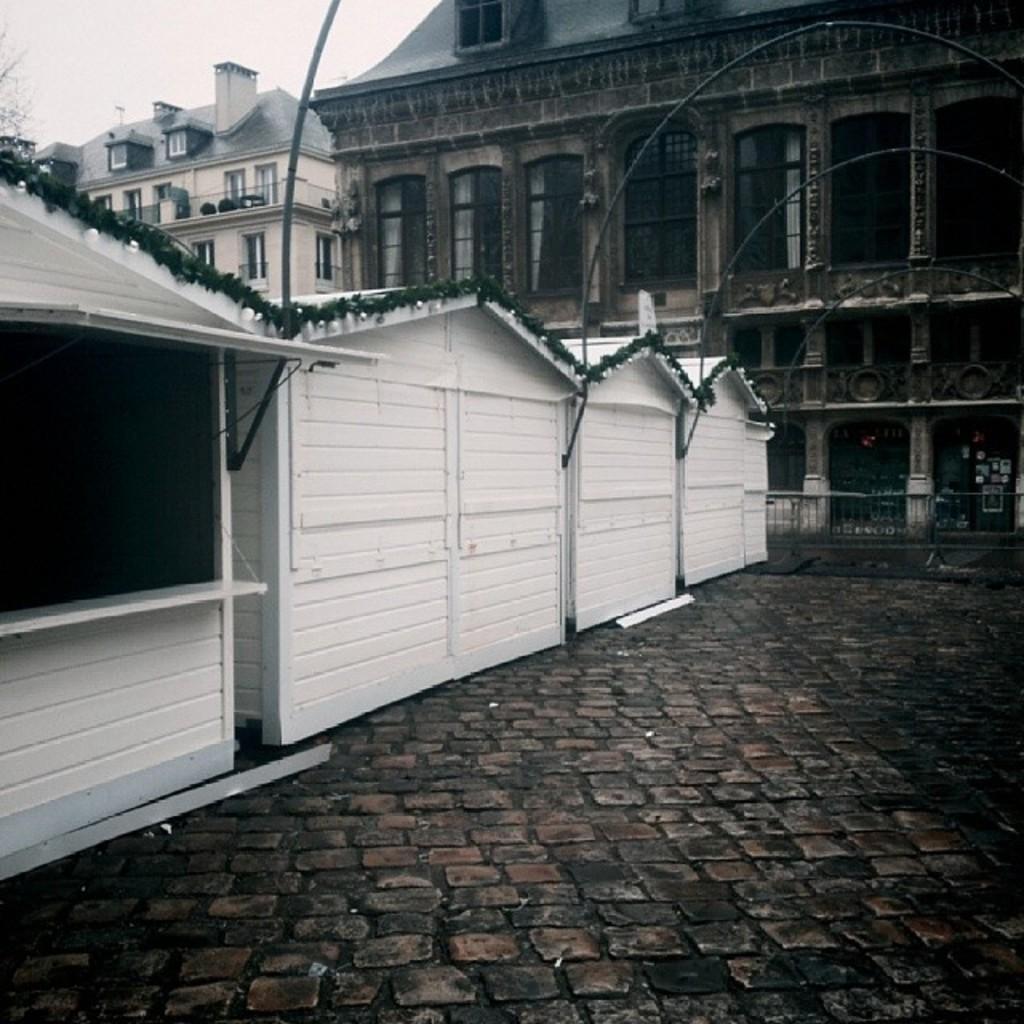Could you give a brief overview of what you see in this image? In the middle of the image there are some sheds. Behind the sheds there are some buildings and trees. At the top of the image there is sky. 